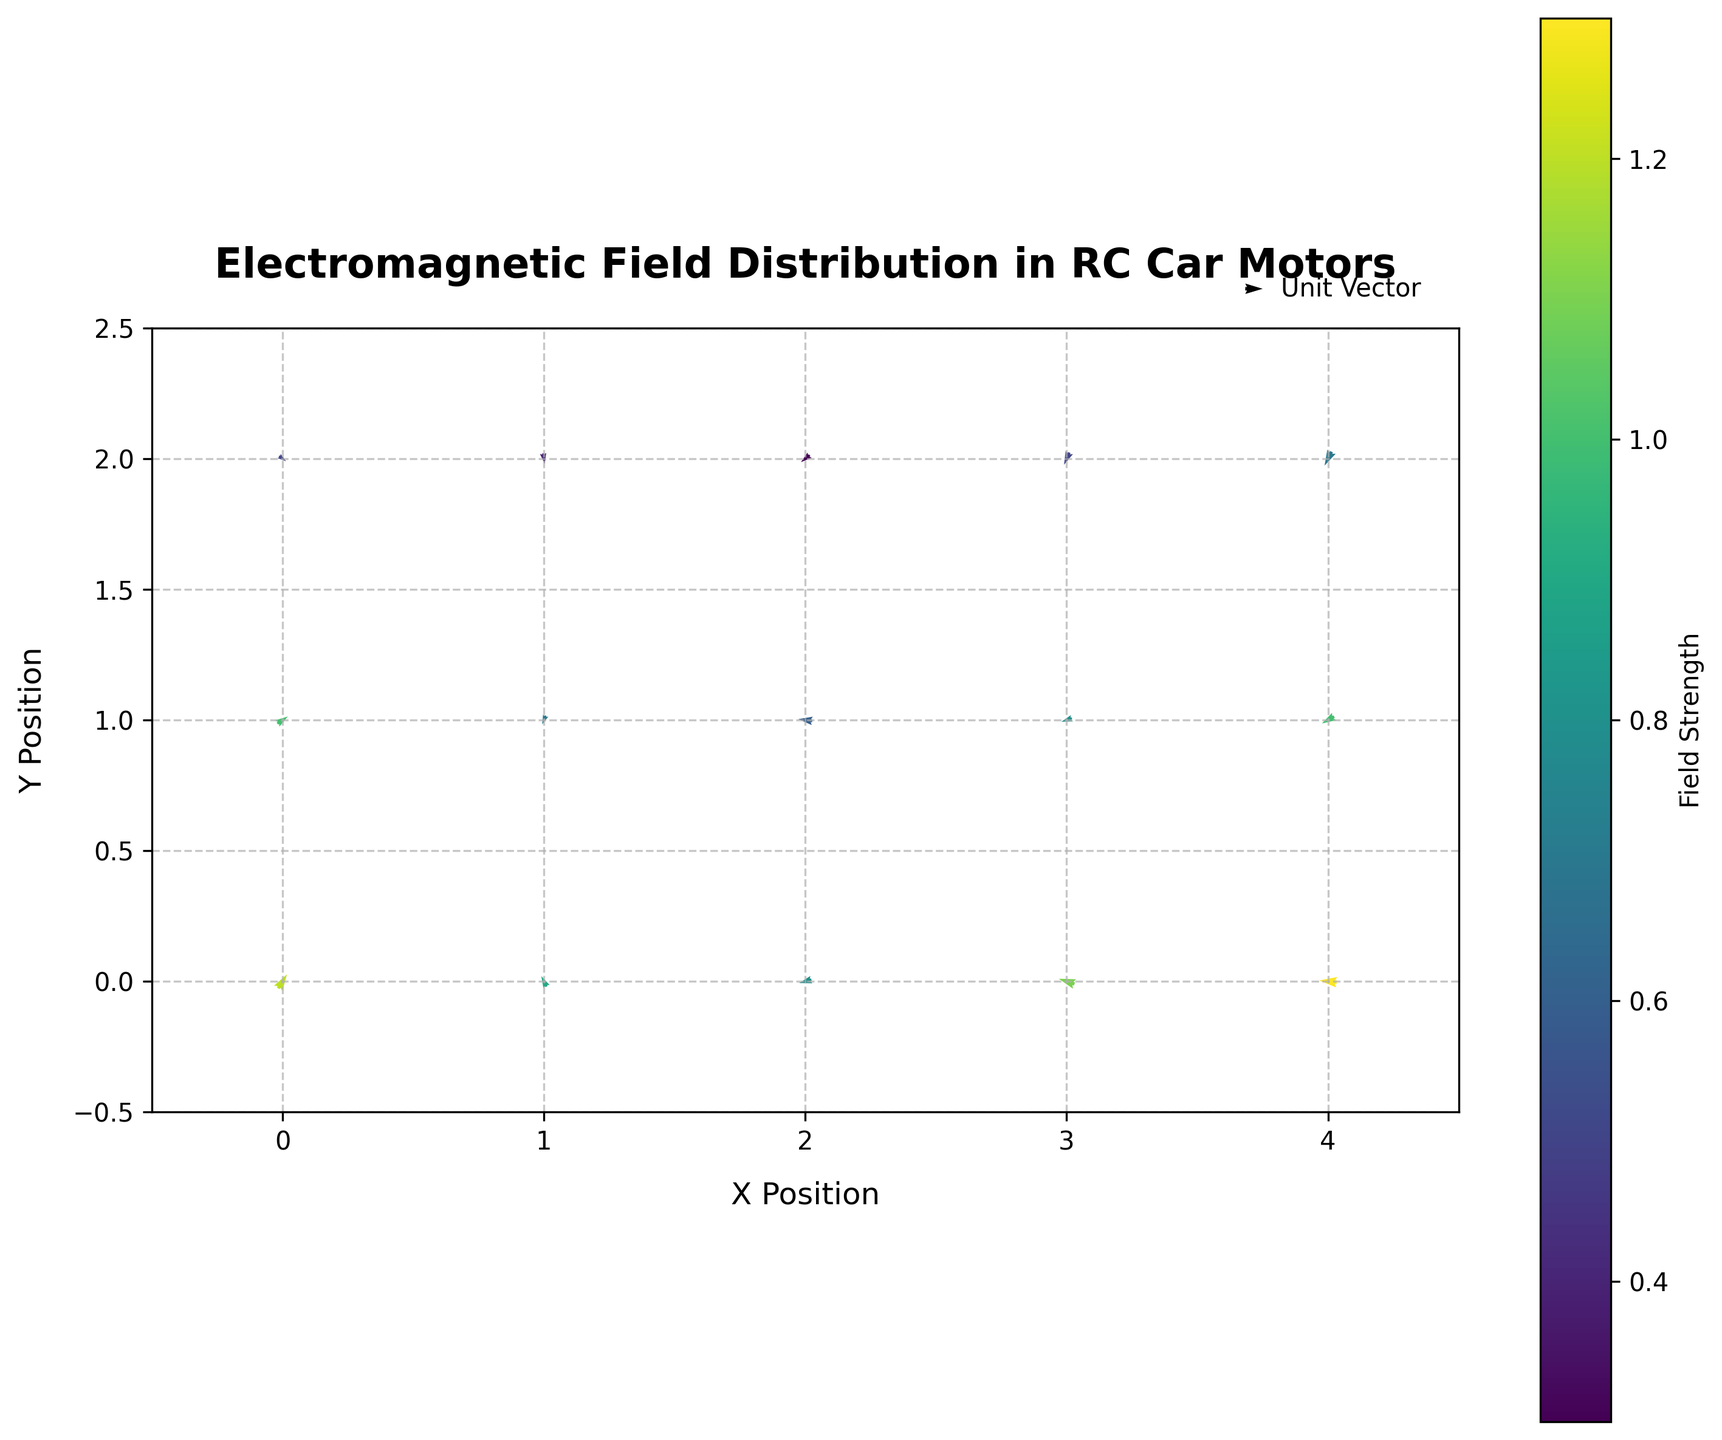What is the title of the plot? The title of the plot can be seen at the top of the figure. It reads "Electromagnetic Field Distribution in RC Car Motors".
Answer: Electromagnetic Field Distribution in RC Car Motors What's the range of the x-axis? The plot's x-axis range is determined by the smallest and largest x-values visible on the plot. The x-axis extends from -0.5 to 4.5.
Answer: -0.5 to 4.5 How is the field strength represented on this plot? The field strength is represented using color gradients. Darker colors correspond to higher strengths, as indicated by the color bar on the right side of the plot.
Answer: Color gradients Which vector has the highest field strength? By observing the color gradient, the vector at position (4,0) displays the darkest color. Cross-referencing with the data shows this vector has a field strength of 1.3, the highest in the dataset.
Answer: (4, 0) What is the direction and magnitude of the vector at position (1, 2)? The arrow at (1, 2) points downward towards the left. By examining the vector data, the direction components are (u=0.1, v=-0.6), and it has a magnitude of 0.4.
Answer: Down-left, magnitude 0.4 Compare the vectors at position (2,1) and (4,1). Which one has a greater magnitude? By examining their field strengths shown by the color gradient, the vector at (2,1) is lighter than the one at (4,1). Cross-referencing the dataset, the magnitudes are 0.6 and 1.0 respectively.
Answer: (4,1) What general direction do most of the vectors at y=0 point to? By visually inspecting the vectors along y=0, most of them point in a leftward or downward direction.
Answer: Leftward or downward What is the sum of the field strengths at positions (2,1) and (3,1)? To find the sum of field strengths, check their individual strengths from the dataset: 0.6 (for position (2,1)) and 0.8 (for position (3,1)). Adding them together gives 0.6 + 0.8 = 1.4.
Answer: 1.4 